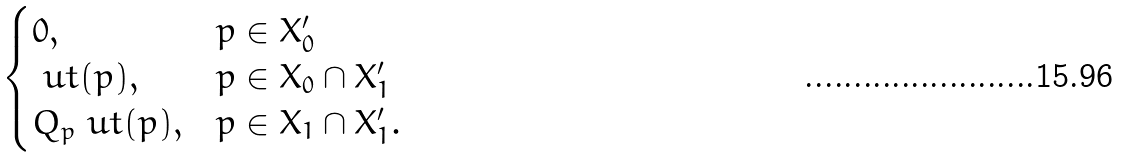Convert formula to latex. <formula><loc_0><loc_0><loc_500><loc_500>\begin{cases} 0 , & p \in X ^ { \prime } _ { 0 } \\ \ u t ( p ) , & p \in X _ { 0 } \cap X ^ { \prime } _ { 1 } \\ Q _ { p } \ u t ( p ) , & p \in X _ { 1 } \cap X ^ { \prime } _ { 1 } . \end{cases}</formula> 